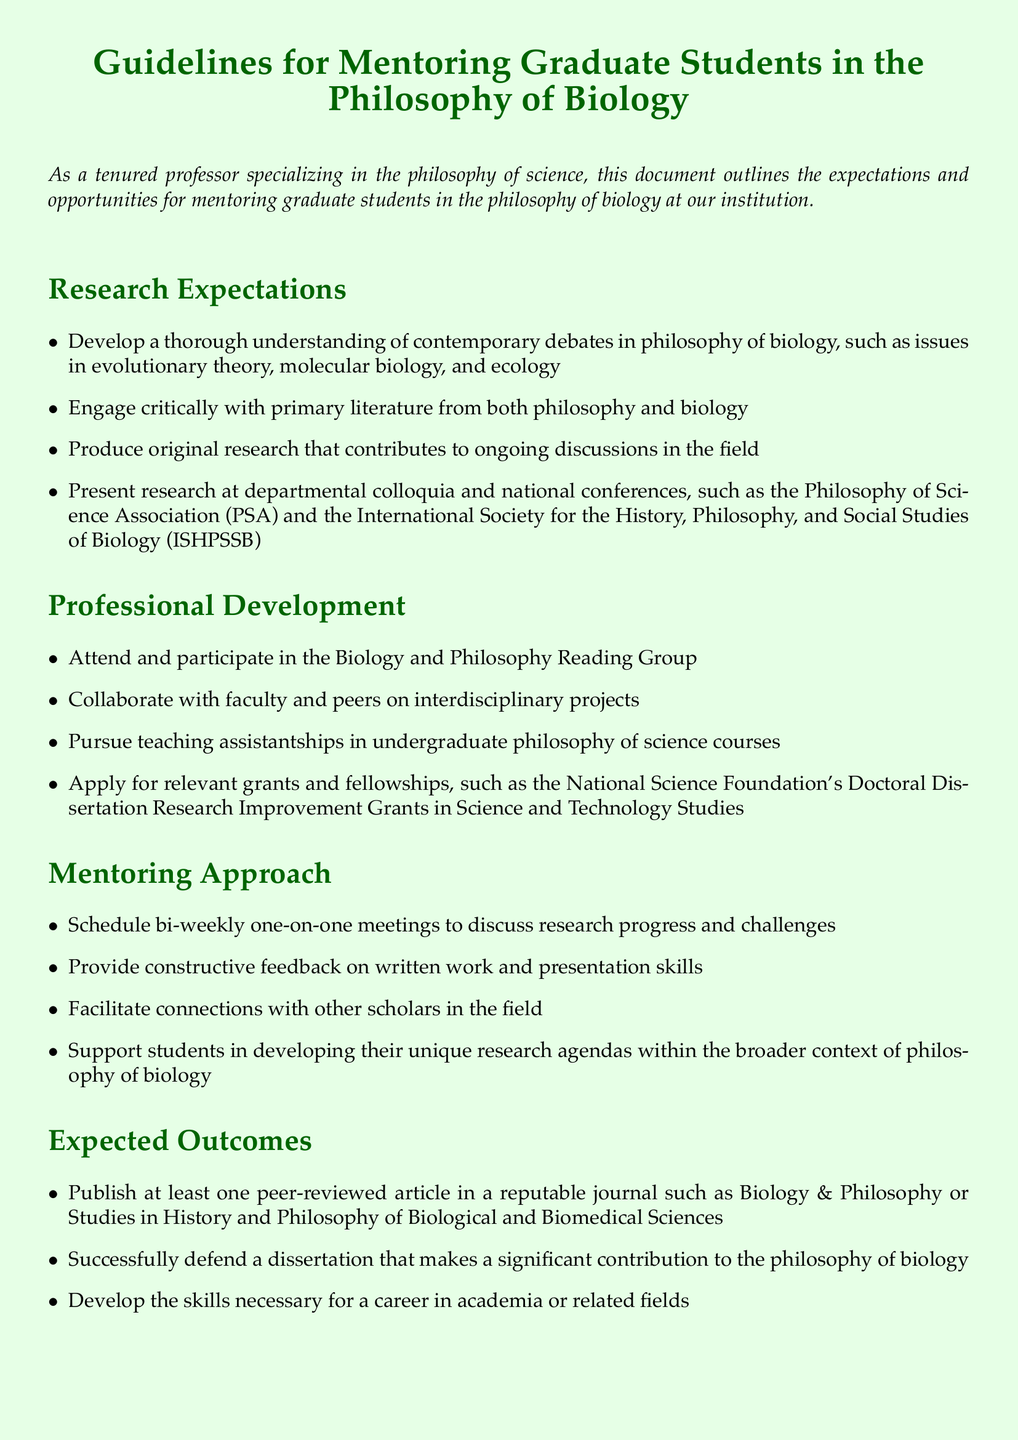What is the title of the document? The title is presented at the beginning of the document, clearly stating the purpose.
Answer: Guidelines for Mentoring Graduate Students in the Philosophy of Biology What is one of the research expectations listed? The document specifies various expectations under research, one of which is engaging with primary literature.
Answer: Engage critically with primary literature from both philosophy and biology Which reading group should students attend for professional development? A specific activity for professional development is mentioned in the document, highlighting interdisciplinary engagement.
Answer: Biology and Philosophy Reading Group How often should meetings be scheduled between the mentor and graduate students? The mentoring approach section specifies the frequency of these important meetings for guidance.
Answer: Bi-weekly What is one expected outcome for students mentioned in the document? The document outlines several expected outcomes regarding students' achievements, including publishing research findings.
Answer: Publish at least one peer-reviewed article What collaboration opportunity is suggested in the professional development section? The document mentions collaboration as a key aspect of professional growth within the program.
Answer: Collaborate with faculty and peers on interdisciplinary projects 